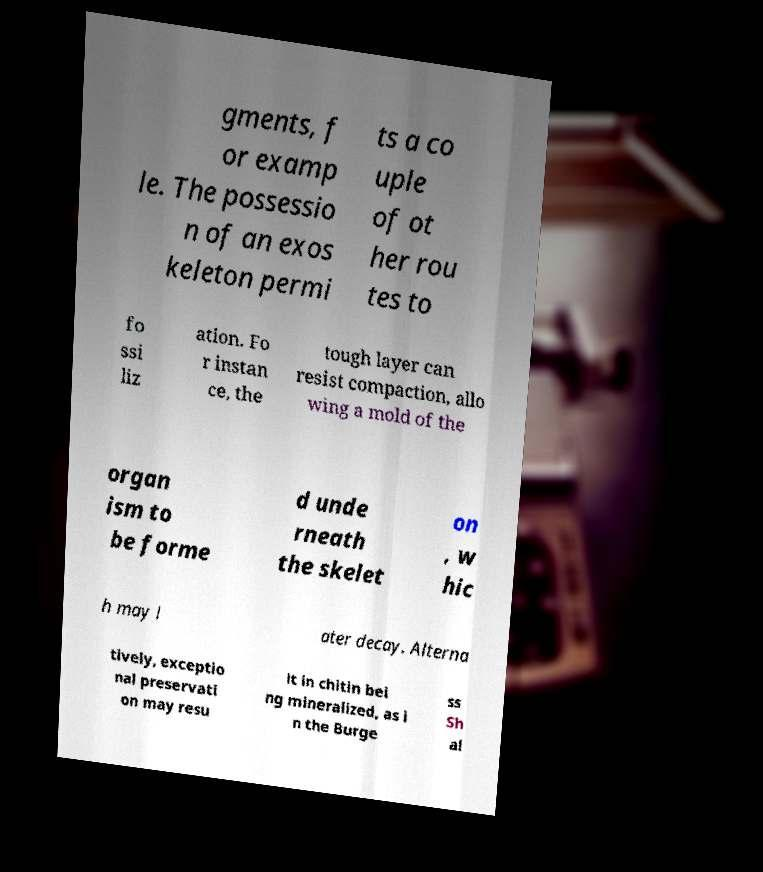Please read and relay the text visible in this image. What does it say? gments, f or examp le. The possessio n of an exos keleton permi ts a co uple of ot her rou tes to fo ssi liz ation. Fo r instan ce, the tough layer can resist compaction, allo wing a mold of the organ ism to be forme d unde rneath the skelet on , w hic h may l ater decay. Alterna tively, exceptio nal preservati on may resu lt in chitin bei ng mineralized, as i n the Burge ss Sh al 